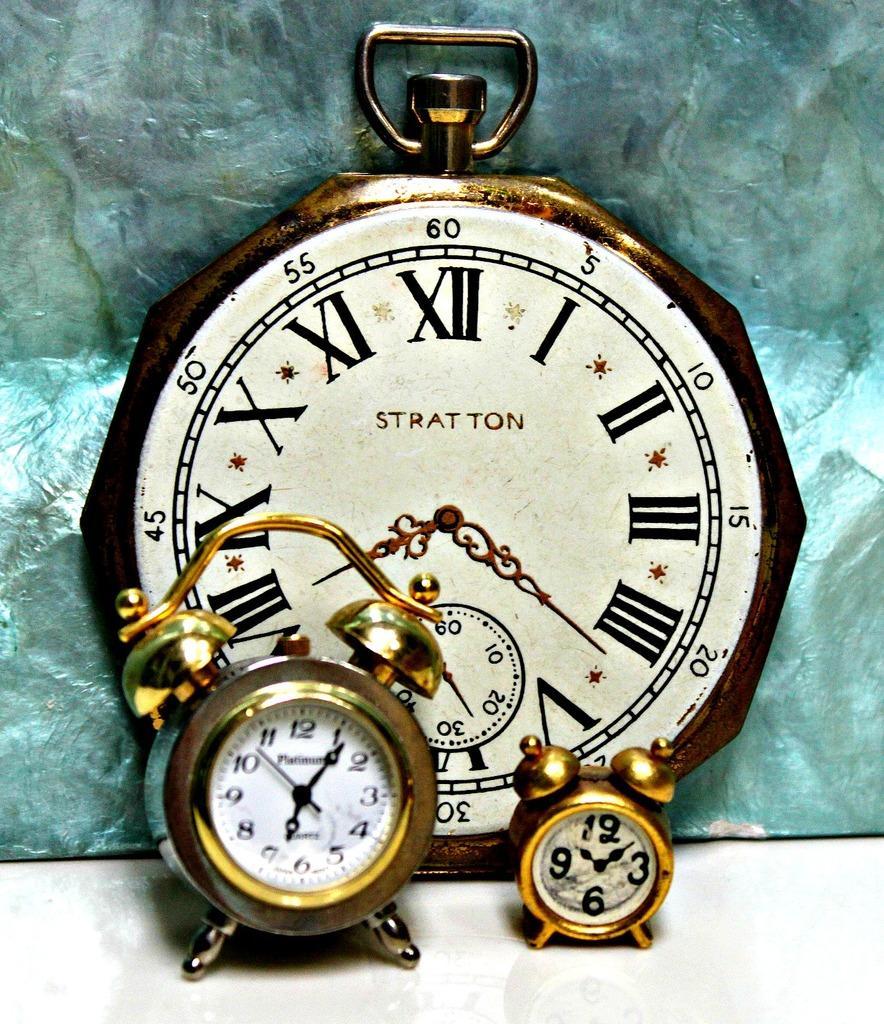How would you summarize this image in a sentence or two? In this picture there are clocks. At the bottom it is white. In the background there is a blue color object. 